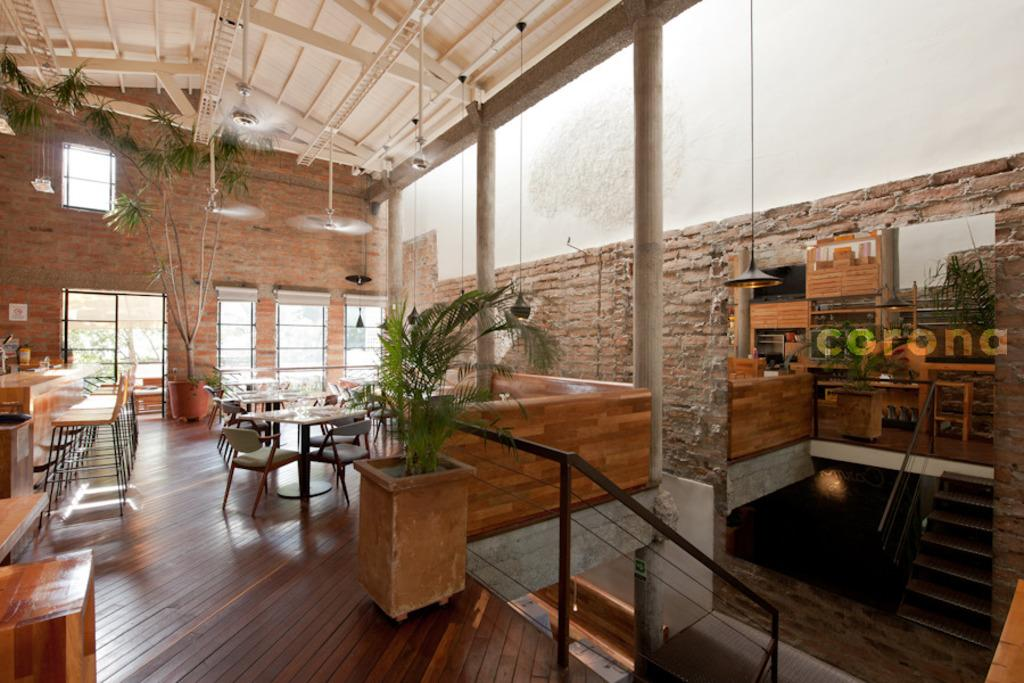What type of setting is shown in the image? The image depicts an interior view of a building. What kind of vegetation can be seen in the image? There are plants in the image. What furniture is present in the image? There are tables and chairs in the image. What material is used for the rods in the image? Metal rods are present in the image. What method of digestion is being taught in the image? There is no teaching or digestion present in the image; it depicts an interior view of a building with plants, furniture, and metal rods. 